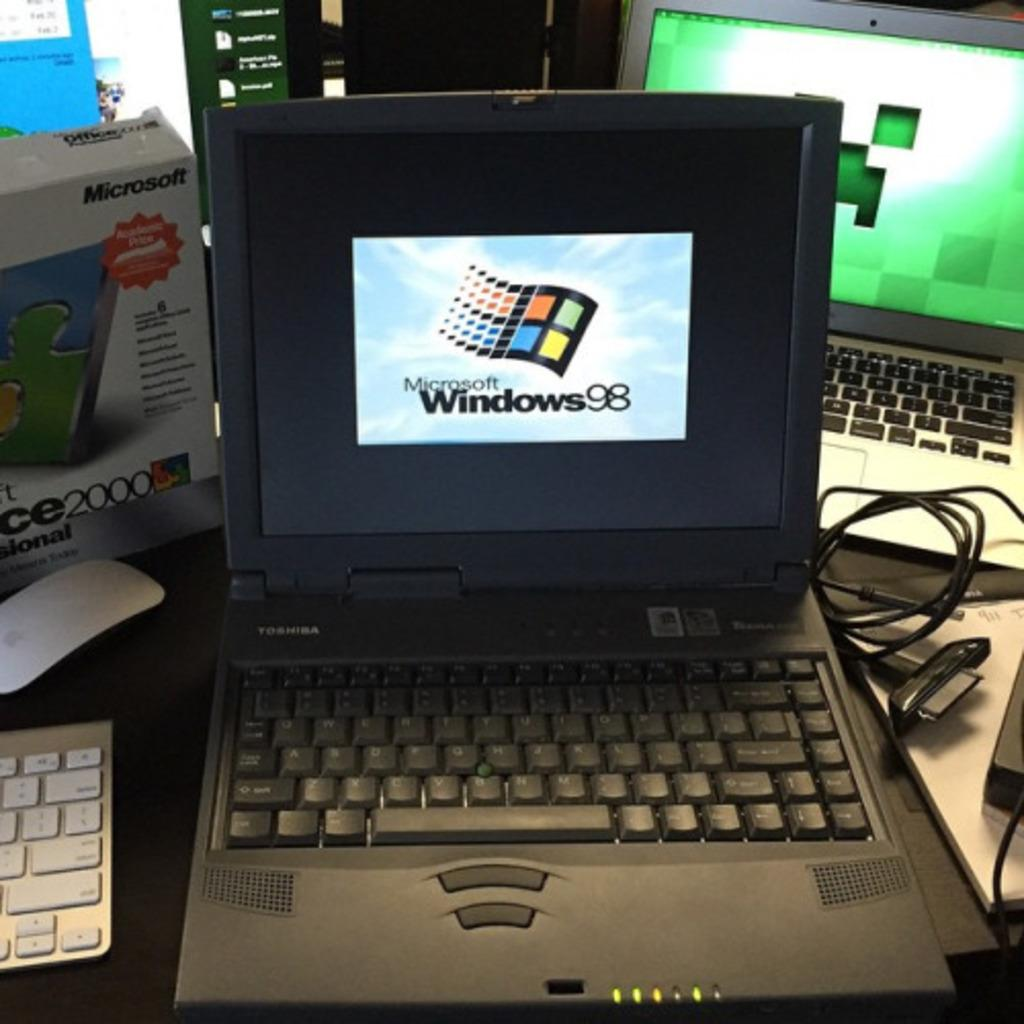<image>
Provide a brief description of the given image. A laptop running Moscrosoft Windows 98 software sits on a table with some other computers and computer equipment. 